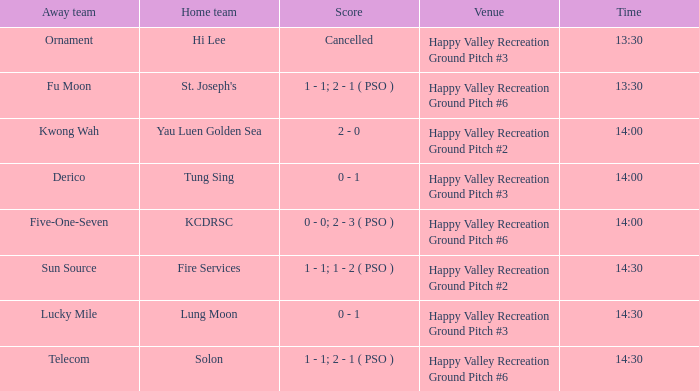What is the away team when solon was the home team? Telecom. 